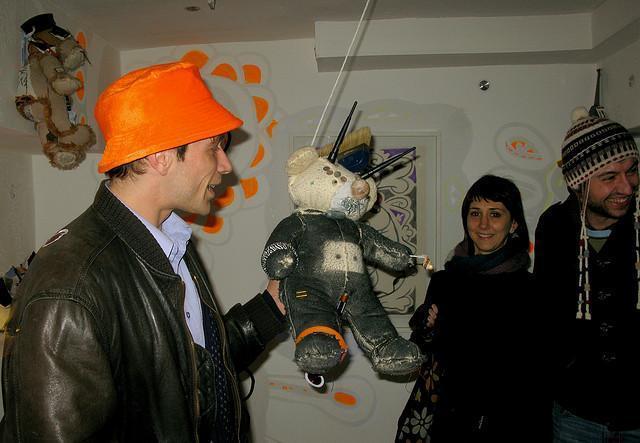How many people can be seen?
Give a very brief answer. 3. 